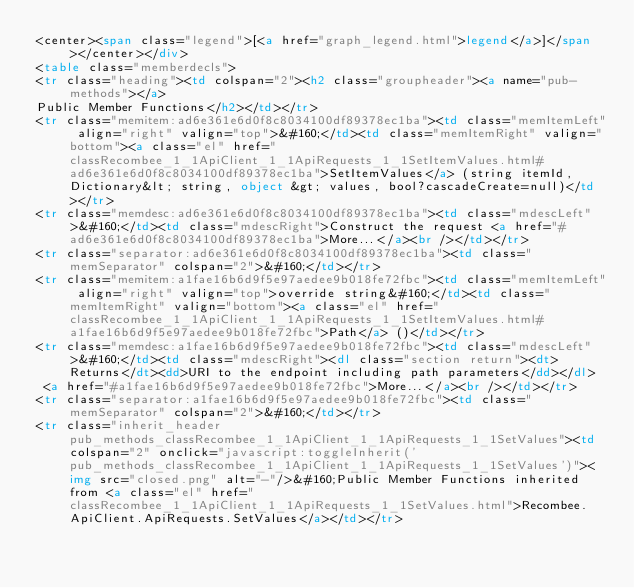<code> <loc_0><loc_0><loc_500><loc_500><_HTML_><center><span class="legend">[<a href="graph_legend.html">legend</a>]</span></center></div>
<table class="memberdecls">
<tr class="heading"><td colspan="2"><h2 class="groupheader"><a name="pub-methods"></a>
Public Member Functions</h2></td></tr>
<tr class="memitem:ad6e361e6d0f8c8034100df89378ec1ba"><td class="memItemLeft" align="right" valign="top">&#160;</td><td class="memItemRight" valign="bottom"><a class="el" href="classRecombee_1_1ApiClient_1_1ApiRequests_1_1SetItemValues.html#ad6e361e6d0f8c8034100df89378ec1ba">SetItemValues</a> (string itemId, Dictionary&lt; string, object &gt; values, bool?cascadeCreate=null)</td></tr>
<tr class="memdesc:ad6e361e6d0f8c8034100df89378ec1ba"><td class="mdescLeft">&#160;</td><td class="mdescRight">Construct the request <a href="#ad6e361e6d0f8c8034100df89378ec1ba">More...</a><br /></td></tr>
<tr class="separator:ad6e361e6d0f8c8034100df89378ec1ba"><td class="memSeparator" colspan="2">&#160;</td></tr>
<tr class="memitem:a1fae16b6d9f5e97aedee9b018fe72fbc"><td class="memItemLeft" align="right" valign="top">override string&#160;</td><td class="memItemRight" valign="bottom"><a class="el" href="classRecombee_1_1ApiClient_1_1ApiRequests_1_1SetItemValues.html#a1fae16b6d9f5e97aedee9b018fe72fbc">Path</a> ()</td></tr>
<tr class="memdesc:a1fae16b6d9f5e97aedee9b018fe72fbc"><td class="mdescLeft">&#160;</td><td class="mdescRight"><dl class="section return"><dt>Returns</dt><dd>URI to the endpoint including path parameters</dd></dl>
 <a href="#a1fae16b6d9f5e97aedee9b018fe72fbc">More...</a><br /></td></tr>
<tr class="separator:a1fae16b6d9f5e97aedee9b018fe72fbc"><td class="memSeparator" colspan="2">&#160;</td></tr>
<tr class="inherit_header pub_methods_classRecombee_1_1ApiClient_1_1ApiRequests_1_1SetValues"><td colspan="2" onclick="javascript:toggleInherit('pub_methods_classRecombee_1_1ApiClient_1_1ApiRequests_1_1SetValues')"><img src="closed.png" alt="-"/>&#160;Public Member Functions inherited from <a class="el" href="classRecombee_1_1ApiClient_1_1ApiRequests_1_1SetValues.html">Recombee.ApiClient.ApiRequests.SetValues</a></td></tr></code> 